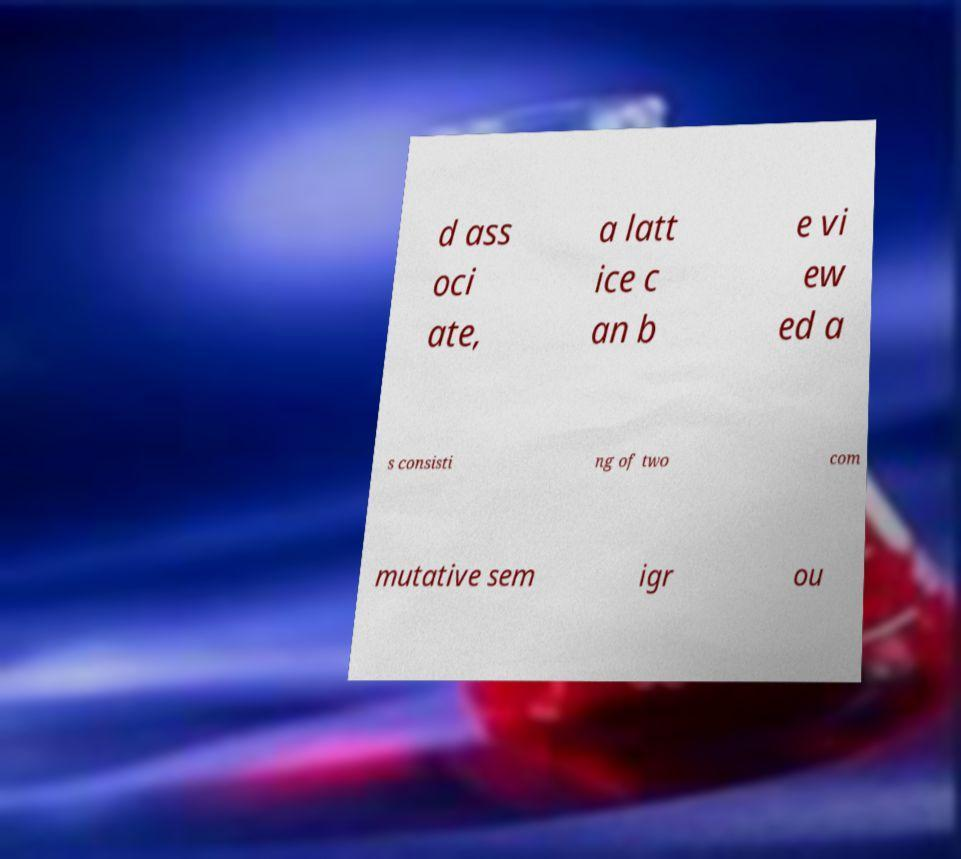What messages or text are displayed in this image? I need them in a readable, typed format. d ass oci ate, a latt ice c an b e vi ew ed a s consisti ng of two com mutative sem igr ou 